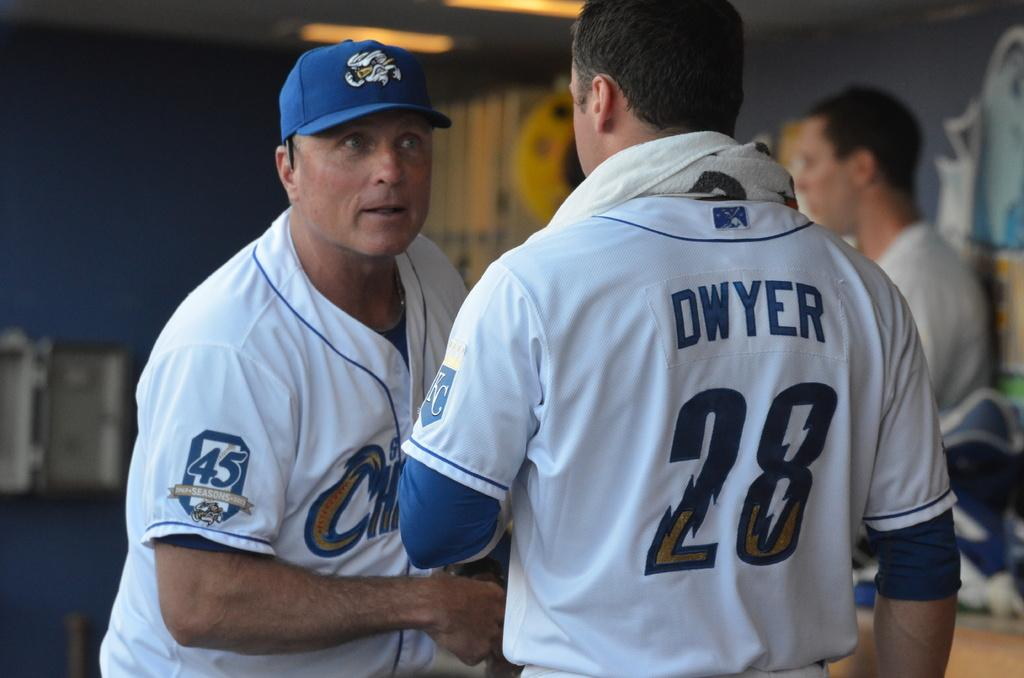Provide a one-sentence caption for the provided image. A man staring at another man as he wears a baseball uniform with the name Dwyer 28 on it. 